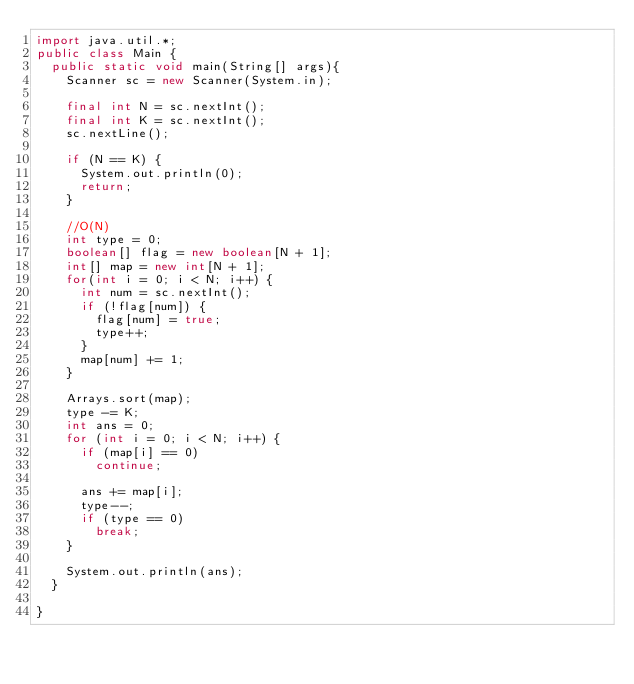<code> <loc_0><loc_0><loc_500><loc_500><_Java_>import java.util.*;
public class Main {
	public static void main(String[] args){
		Scanner sc = new Scanner(System.in);
		
		final int N = sc.nextInt();
		final int K = sc.nextInt();
		sc.nextLine();
		
		if (N == K) {
			System.out.println(0);
			return;
		}
		
		//O(N)
		int type = 0;
		boolean[] flag = new boolean[N + 1];
		int[] map = new int[N + 1];
		for(int i = 0; i < N; i++) {
			int num = sc.nextInt();
			if (!flag[num]) {
				flag[num] = true;
				type++;
			}
			map[num] += 1;
		}
		
		Arrays.sort(map);
		type -= K;
		int ans = 0;
		for (int i = 0; i < N; i++) {
			if (map[i] == 0)
				continue;
			
			ans += map[i];
			type--;
			if (type == 0)
				break;
		}
		
		System.out.println(ans);
	}
	
}
</code> 